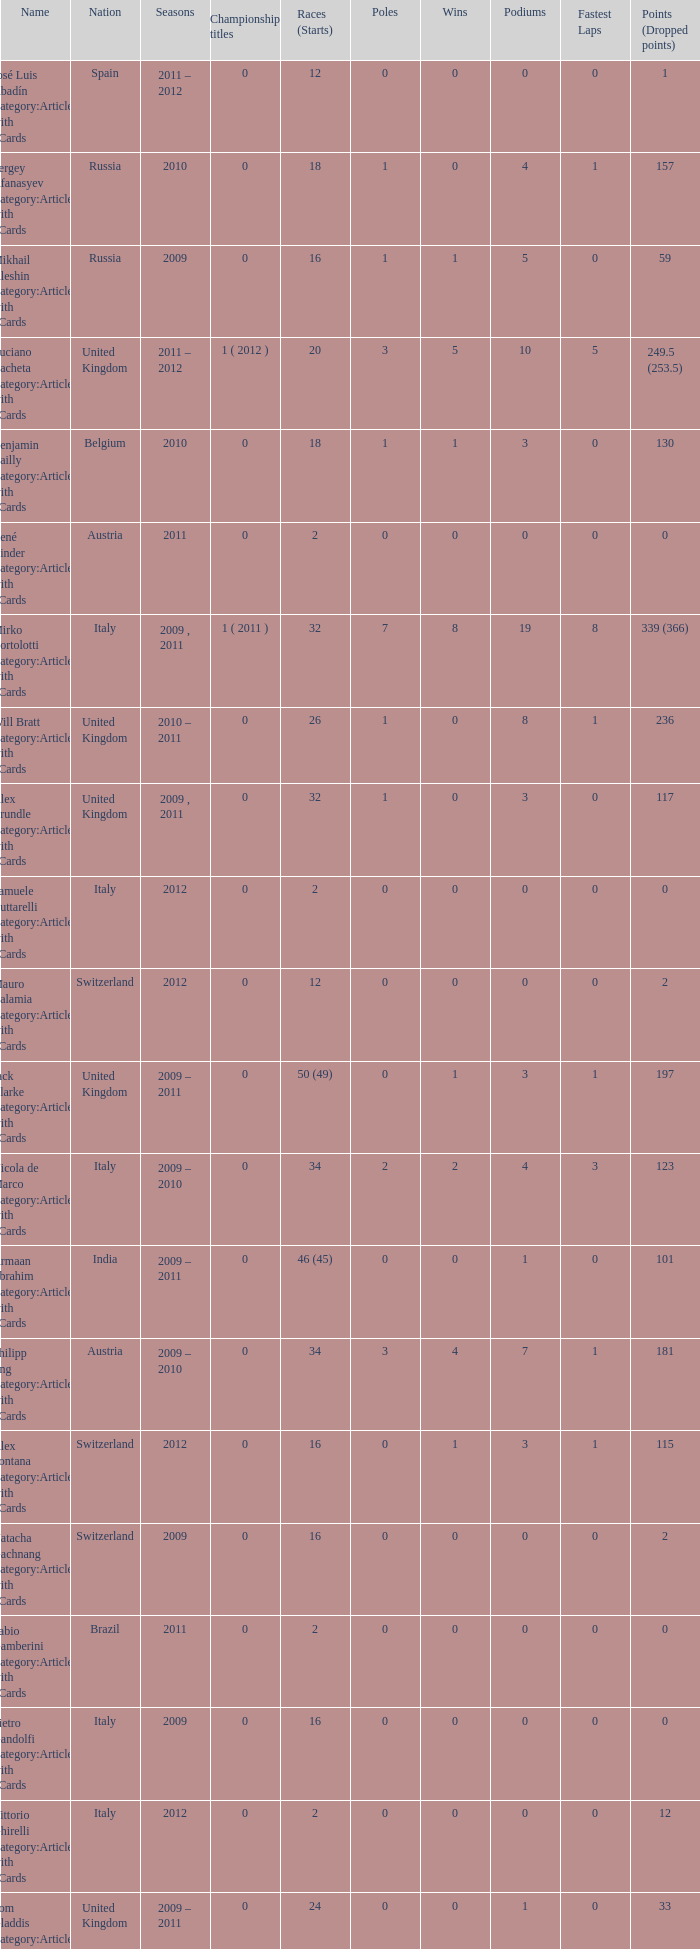When did they win 7 races? 2009.0. 